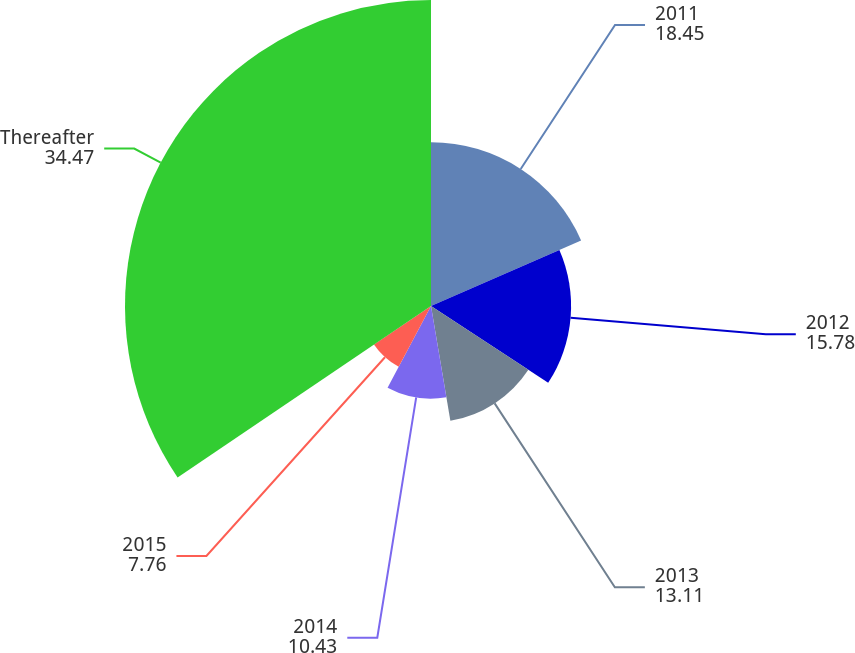Convert chart. <chart><loc_0><loc_0><loc_500><loc_500><pie_chart><fcel>2011<fcel>2012<fcel>2013<fcel>2014<fcel>2015<fcel>Thereafter<nl><fcel>18.45%<fcel>15.78%<fcel>13.11%<fcel>10.43%<fcel>7.76%<fcel>34.47%<nl></chart> 